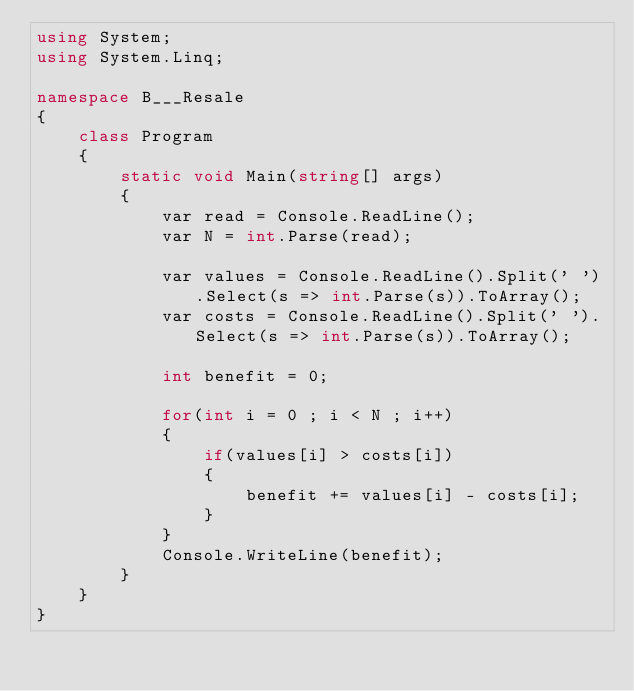Convert code to text. <code><loc_0><loc_0><loc_500><loc_500><_C#_>using System;
using System.Linq;

namespace B___Resale
{
    class Program
    {
        static void Main(string[] args)
        {
            var read = Console.ReadLine();
            var N = int.Parse(read);

            var values = Console.ReadLine().Split(' ').Select(s => int.Parse(s)).ToArray();
            var costs = Console.ReadLine().Split(' ').Select(s => int.Parse(s)).ToArray();

            int benefit = 0;

            for(int i = 0 ; i < N ; i++)
            {
                if(values[i] > costs[i])
                {
                    benefit += values[i] - costs[i];
                }
            }
            Console.WriteLine(benefit);
        }
    }
}
</code> 